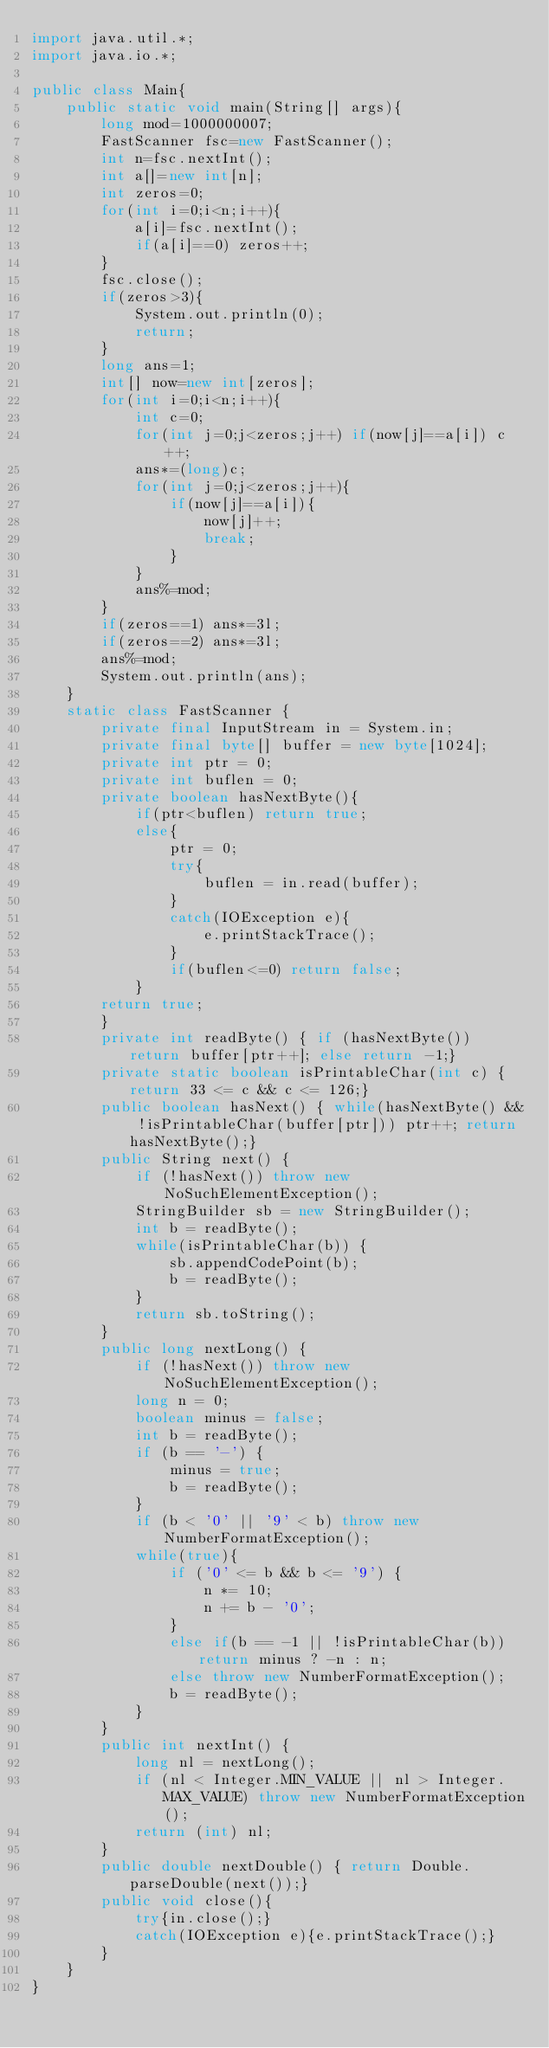Convert code to text. <code><loc_0><loc_0><loc_500><loc_500><_Java_>import java.util.*;
import java.io.*;

public class Main{
    public static void main(String[] args){
        long mod=1000000007;
        FastScanner fsc=new FastScanner();
        int n=fsc.nextInt();
        int a[]=new int[n];
        int zeros=0;
        for(int i=0;i<n;i++){
            a[i]=fsc.nextInt();
            if(a[i]==0) zeros++;
        }
        fsc.close();
        if(zeros>3){
            System.out.println(0);
            return;
        }
        long ans=1;
        int[] now=new int[zeros];
        for(int i=0;i<n;i++){
            int c=0;
            for(int j=0;j<zeros;j++) if(now[j]==a[i]) c++;
            ans*=(long)c;
            for(int j=0;j<zeros;j++){
                if(now[j]==a[i]){
                    now[j]++;
                    break;
                }
            }
            ans%=mod;
        }
        if(zeros==1) ans*=3l;
        if(zeros==2) ans*=3l;
        ans%=mod;
        System.out.println(ans);
    }
    static class FastScanner {
        private final InputStream in = System.in;
        private final byte[] buffer = new byte[1024];
        private int ptr = 0;
        private int buflen = 0;
        private boolean hasNextByte(){
            if(ptr<buflen) return true;
            else{
                ptr = 0;
                try{
                    buflen = in.read(buffer);
                }
                catch(IOException e){
                    e.printStackTrace();
                }
                if(buflen<=0) return false;
            }
        return true;
        }
        private int readByte() { if (hasNextByte()) return buffer[ptr++]; else return -1;}
        private static boolean isPrintableChar(int c) { return 33 <= c && c <= 126;}
        public boolean hasNext() { while(hasNextByte() && !isPrintableChar(buffer[ptr])) ptr++; return hasNextByte();}
        public String next() {
            if (!hasNext()) throw new NoSuchElementException();
            StringBuilder sb = new StringBuilder();
            int b = readByte();
            while(isPrintableChar(b)) {
                sb.appendCodePoint(b);
                b = readByte();
            }
            return sb.toString();
        }
        public long nextLong() {
            if (!hasNext()) throw new NoSuchElementException();
            long n = 0;
            boolean minus = false;
            int b = readByte();
            if (b == '-') {
                minus = true;
                b = readByte();
            }
            if (b < '0' || '9' < b) throw new NumberFormatException();
            while(true){
                if ('0' <= b && b <= '9') {
                    n *= 10;
                    n += b - '0';
                }
                else if(b == -1 || !isPrintableChar(b)) return minus ? -n : n;
                else throw new NumberFormatException();
                b = readByte();
            }
        }
        public int nextInt() {
            long nl = nextLong();
            if (nl < Integer.MIN_VALUE || nl > Integer.MAX_VALUE) throw new NumberFormatException();
            return (int) nl;
        }
        public double nextDouble() { return Double.parseDouble(next());}
        public void close(){
            try{in.close();}
            catch(IOException e){e.printStackTrace();}
        }
    }
}</code> 